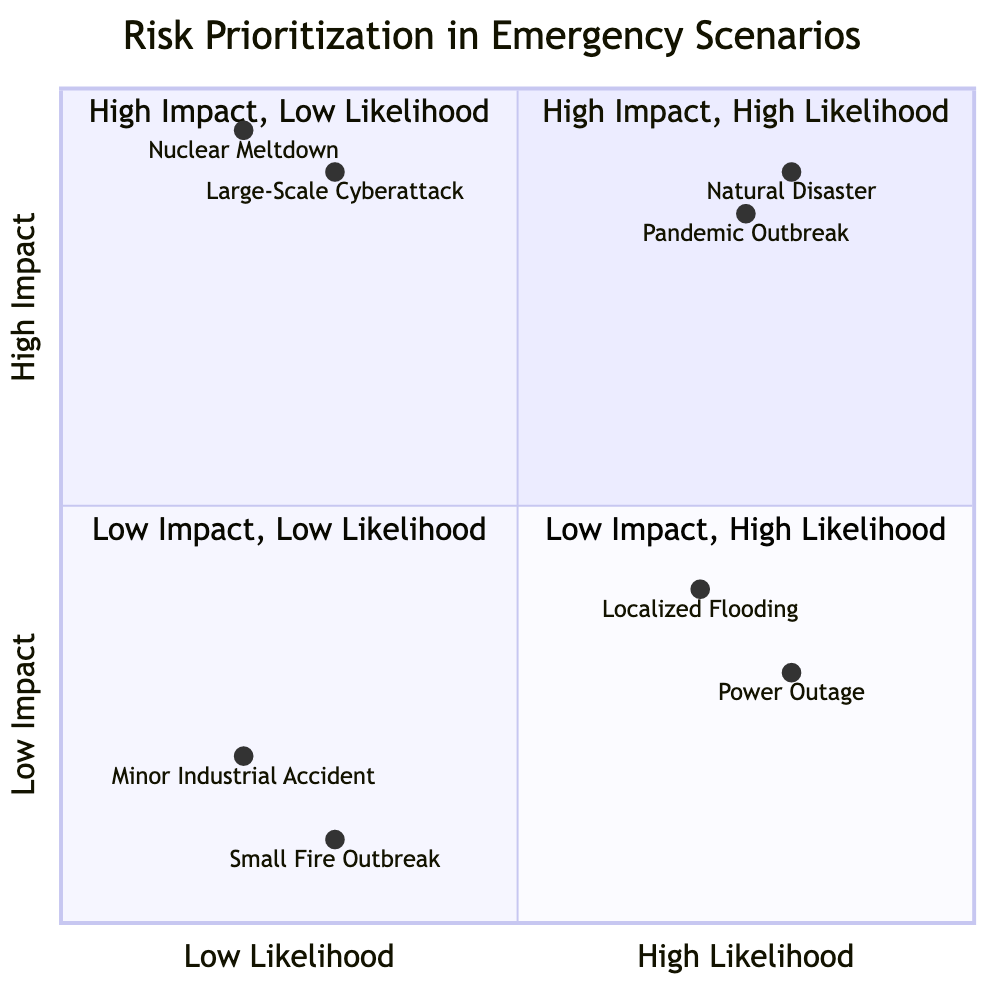What are the two risks in the "High Impact, High Likelihood" quadrant? In the "High Impact, High Likelihood" quadrant, the risks listed are "Natural Disaster" and "Pandemic Outbreak." These are the only two items in that specific quadrant.
Answer: Natural Disaster, Pandemic Outbreak How many risks are plotted in the "Low Impact, Low Likelihood" quadrant? There are two risks plotted in the "Low Impact, Low Likelihood" quadrant: "Minor Industrial Accident" and "Small Fire Outbreak." By counting the items, we identify that quadrant has two risks.
Answer: 2 What is the likelihood value of "Nuclear Meltdown"? The likelihood value for "Nuclear Meltdown" is 0.2, as seen in the data provided for this specific risk point in the diagram.
Answer: 0.2 Which risk has the highest impact according to the diagram? The risk with the highest impact in the diagram is "Nuclear Meltdown," located in the "High Impact, Low Likelihood" quadrant, with an impact value of 0.95.
Answer: Nuclear Meltdown Is "Power Outage" regarded as high impact or low impact? "Power Outage" is considered low impact as it is positioned in the "Low Impact, High Likelihood" quadrant according to the chart's classification.
Answer: Low Impact What is the example given for "Large-Scale Cyberattack"? The example for "Large-Scale Cyberattack" is "Nation-state-sponsored attacks on critical infrastructure," which is explicitly stated in the related data section.
Answer: Nation-state-sponsored attacks on critical infrastructure Which quadrant contains "Localized Flooding"? "Localized Flooding" is found in the "Low Impact, High Likelihood" quadrant. It is categorized there based on its corresponding likelihood and impact values.
Answer: Low Impact, High Likelihood How does the likelihood of "Pandemic Outbreak" compare to "Natural Disaster"? The likelihood of "Pandemic Outbreak" is 0.75, while "Natural Disaster" has a likelihood of 0.8. Thus, "Natural Disaster" has a higher likelihood than "Pandemic Outbreak."
Answer: Higher for Natural Disaster What is the correlation between impact and likelihood for the risks in the "High Impact, High Likelihood" quadrant? Both risks in this quadrant, "Natural Disaster" and "Pandemic Outbreak," have high impact and high likelihood values, indicating that they are highly probable and extremely consequential.
Answer: High correlation 